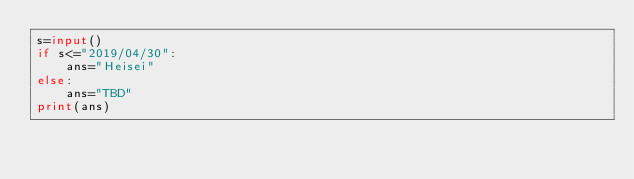Convert code to text. <code><loc_0><loc_0><loc_500><loc_500><_Python_>s=input()
if s<="2019/04/30":
    ans="Heisei"
else:
    ans="TBD"
print(ans)</code> 